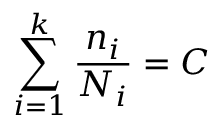<formula> <loc_0><loc_0><loc_500><loc_500>\sum _ { i = 1 } ^ { k } { \frac { n _ { i } } { N _ { i } } } = C</formula> 